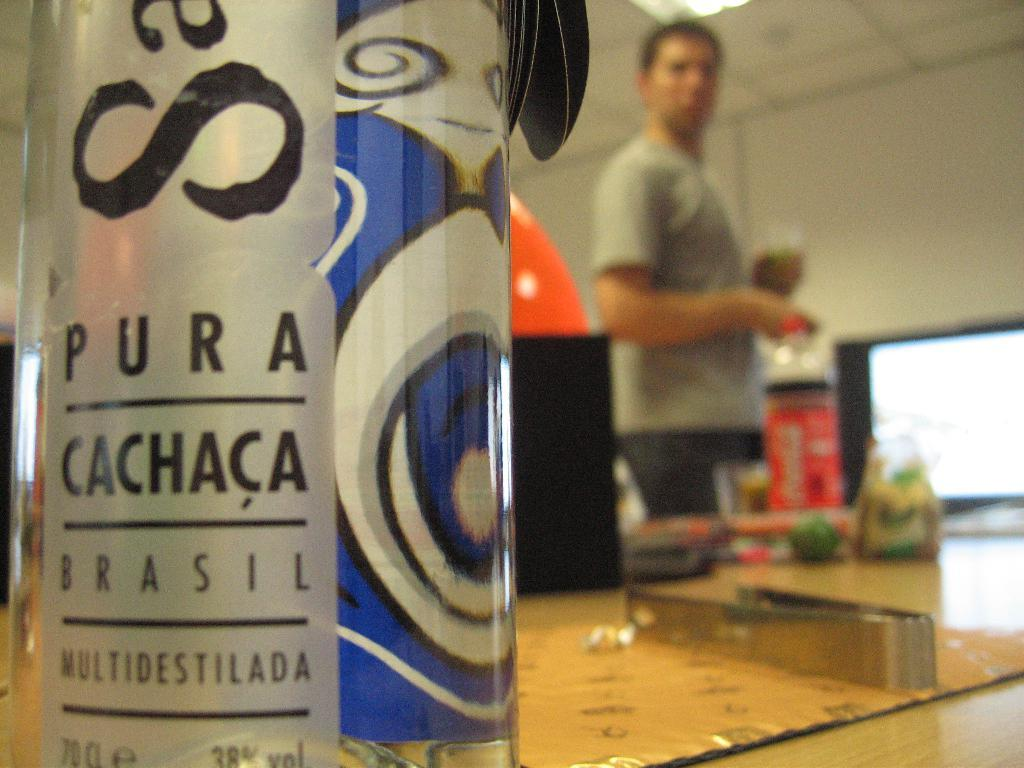<image>
Create a compact narrative representing the image presented. A bottle of pura chaca brasil alcohol, distilled multiple times 